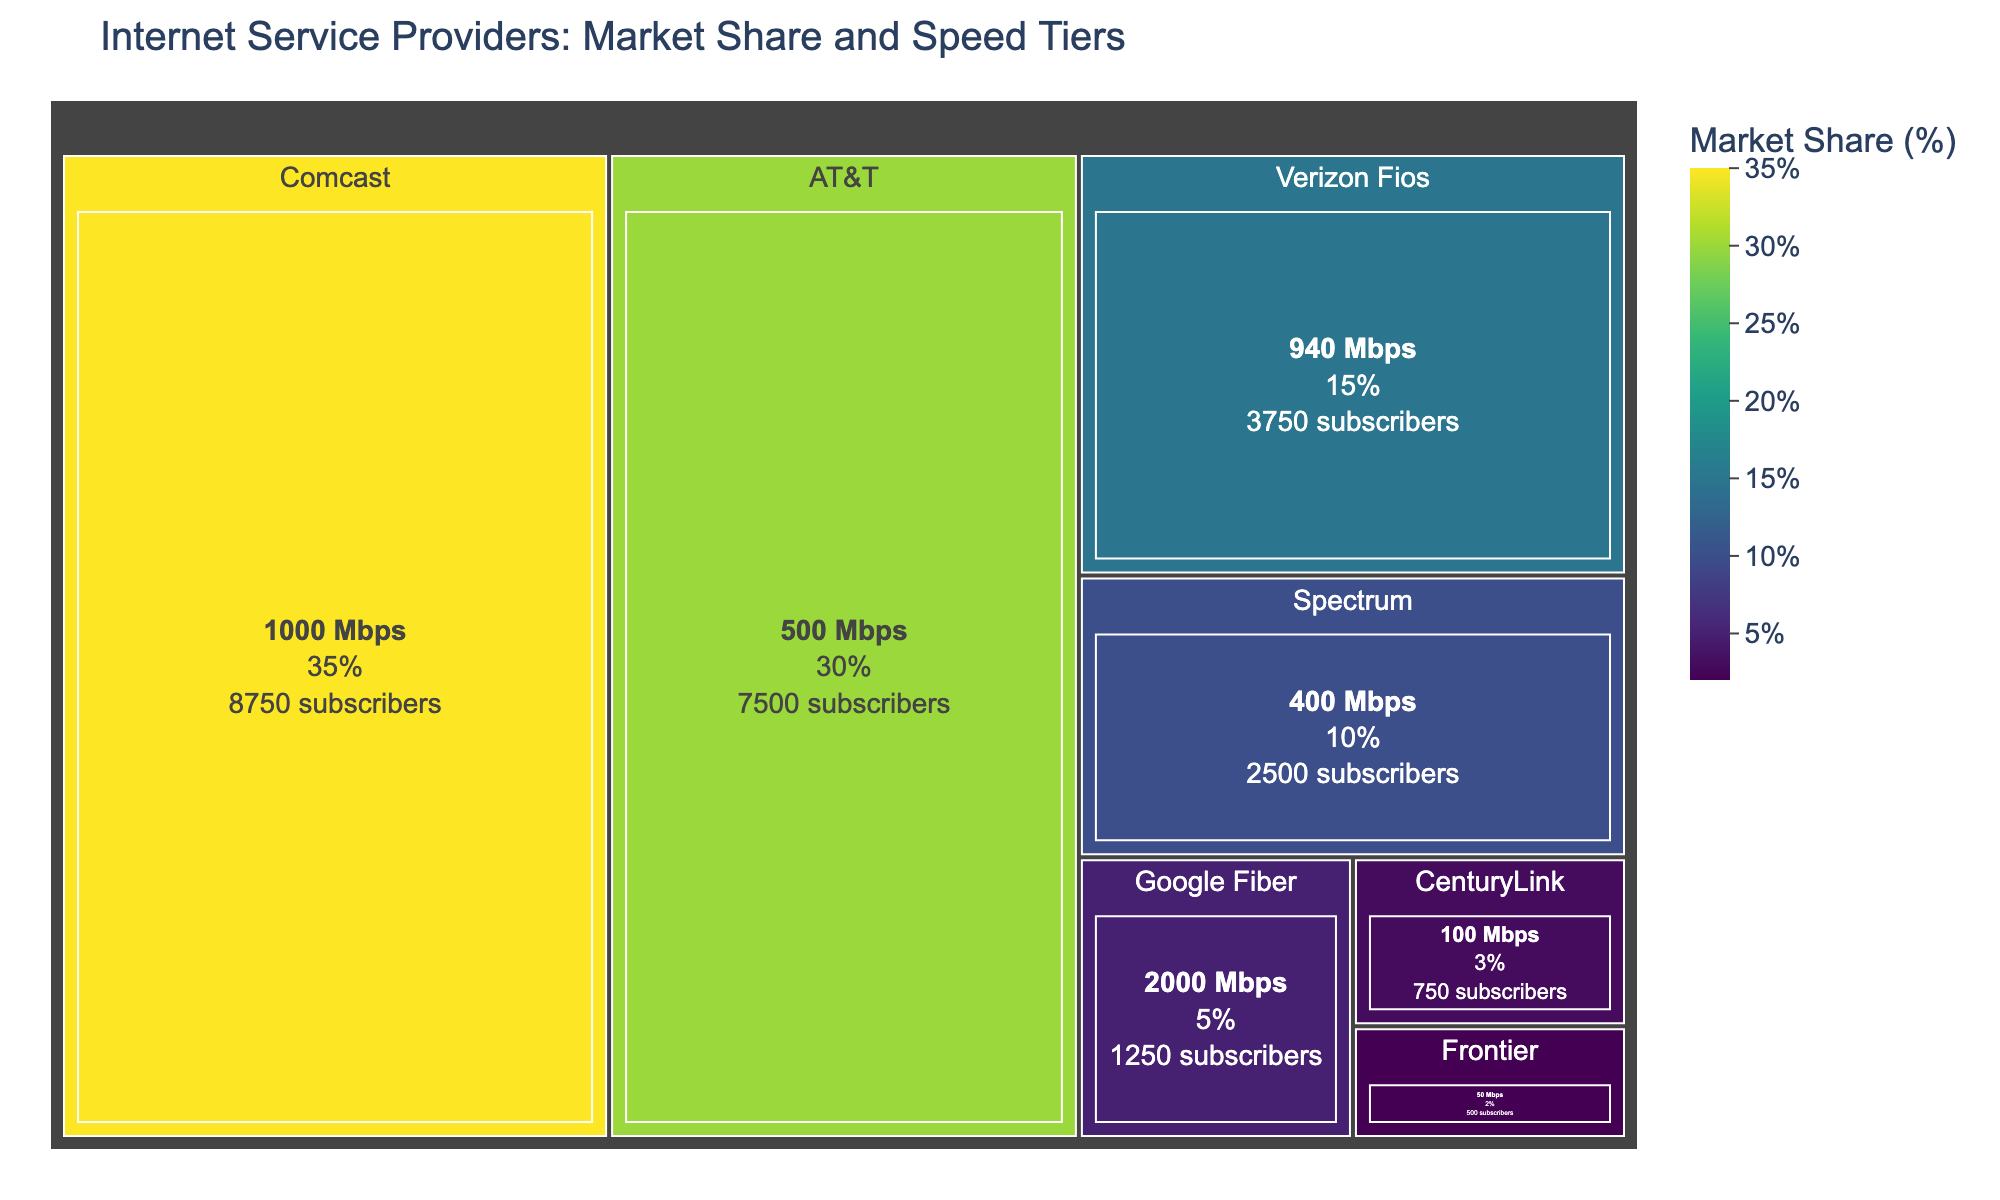Which ISP has the highest market share? By looking at the treemap, we see the area covered by Comcast is the largest, indicating it has the highest market share. The hover data confirms this with 35%.
Answer: Comcast What is the total number of subscribers for ISPs with a speed tier of 1000 Mbps or higher? Comcast has 8750 subscribers with a 1000 Mbps speed tier and Google Fiber has 1250 subscribers with a 2000 Mbps speed tier. Adding these together, 8750 + 1250 = 10000.
Answer: 10000 How does the market share of AT&T compare to that of Verizon Fios? AT&T has a market share of 30%, and Verizon Fios has a market share of 15%. Comparing the two, 30% is greater than 15%.
Answer: AT&T has a greater market share than Verizon Fios Which ISP offers the slowest speed tier, and what is its market share? Frontier offers the slowest speed tier at 50 Mbps, as indicated in the treemap. Its market share is 2%, according to the hover data.
Answer: Frontier, with a market share of 2% How do the number of subscribers for Spectrum and CenturyLink compare? Spectrum has 2500 subscribers, and CenturyLink has 750 subscribers. Spectrum has more subscribers than CenturyLink.
Answer: Spectrum has more subscribers than CenturyLink What is the market share difference between Comcast and Google Fiber? Comcast has a market share of 35%, and Google Fiber has a market share of 5%. The difference is 35% - 5% = 30%.
Answer: 30% Which ISP has the smallest market share, and how many subscribers does it have? Frontier has the smallest market share at 2%. It has 500 subscribers as shown in the treemap.
Answer: Frontier, with 500 subscribers How many ISPs offer a speed tier of 500 Mbps or higher? By looking at the treemap, we see that Comcast (1000 Mbps), AT&T (500 Mbps), Verizon Fios (940 Mbps), and Google Fiber (2000 Mbps) offer speed tiers of 500 Mbps or higher. Counting these ISPs gives us 4.
Answer: 4 What is the combined market share of ISPs offering speed tiers under 500 Mbps? Spectrum (10%), CenturyLink (3%), and Frontier (2%) offer speed tiers under 500 Mbps. Adding these together, 10% + 3% + 2% = 15%.
Answer: 15% What is the speed tier offered by the ISP with the third highest market share, and what is its subscriber count? Verizon Fios has the third highest market share at 15%. It offers a speed tier of 940 Mbps and has 3750 subscribers.
Answer: 940 Mbps, 3750 subscribers 